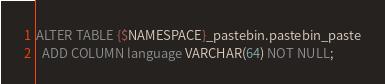<code> <loc_0><loc_0><loc_500><loc_500><_SQL_>ALTER TABLE {$NAMESPACE}_pastebin.pastebin_paste
  ADD COLUMN language VARCHAR(64) NOT NULL;</code> 